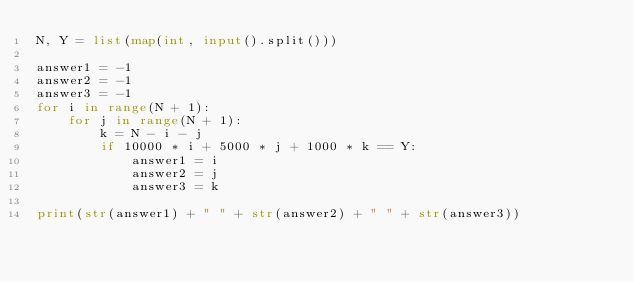<code> <loc_0><loc_0><loc_500><loc_500><_Python_>N, Y = list(map(int, input().split()))

answer1 = -1
answer2 = -1
answer3 = -1
for i in range(N + 1):
    for j in range(N + 1):
        k = N - i - j
        if 10000 * i + 5000 * j + 1000 * k == Y:
            answer1 = i
            answer2 = j
            answer3 = k

print(str(answer1) + " " + str(answer2) + " " + str(answer3))</code> 